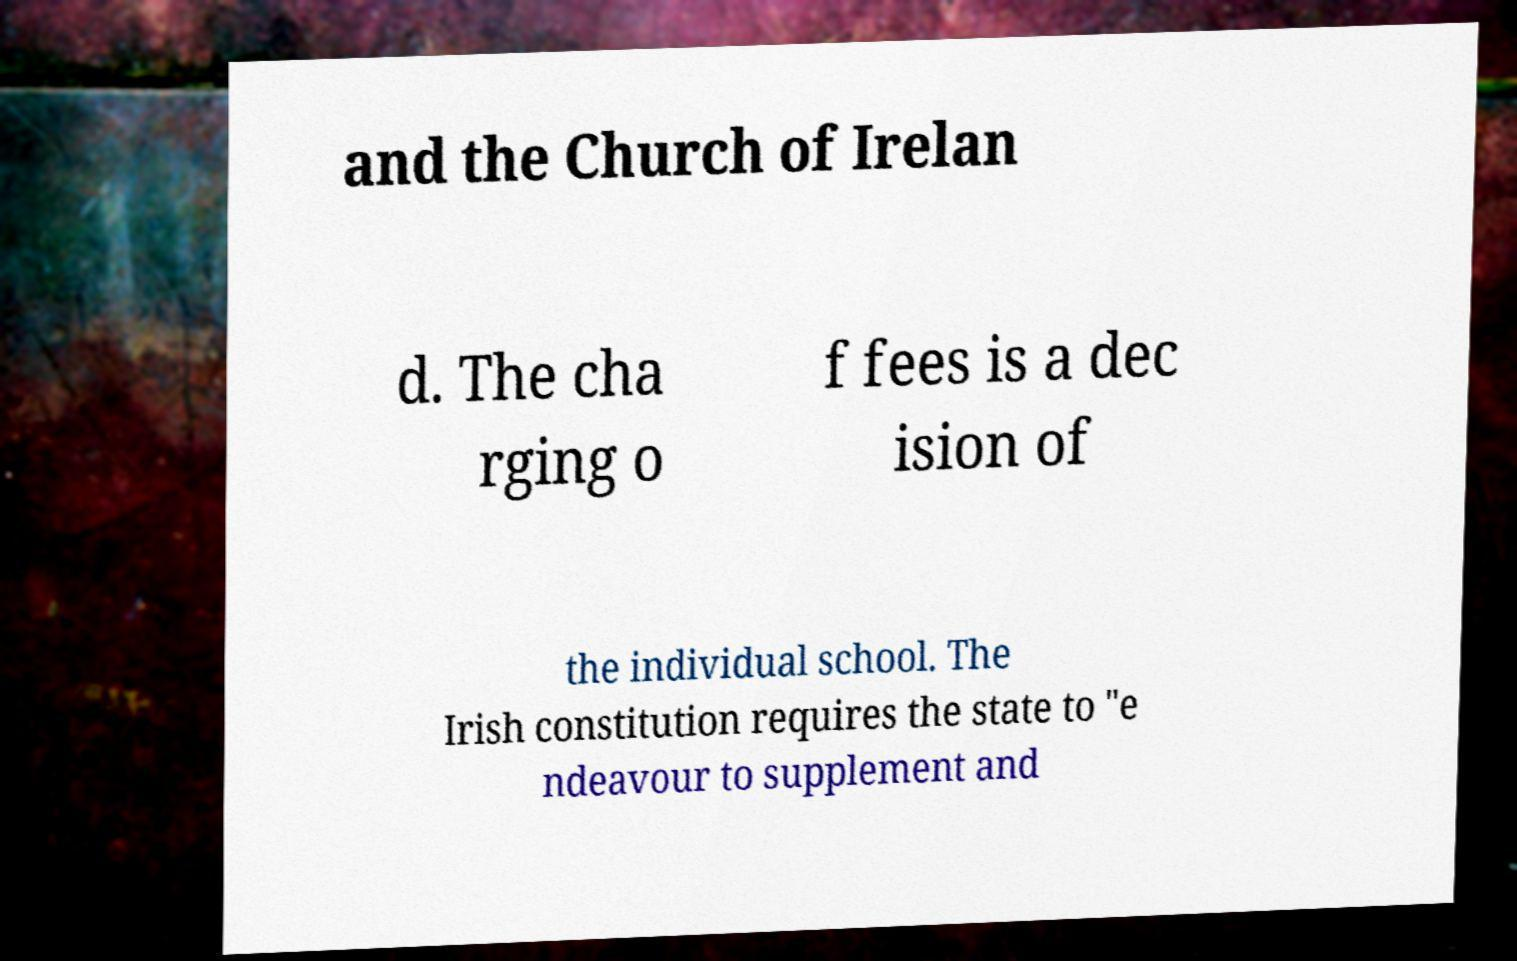Can you accurately transcribe the text from the provided image for me? and the Church of Irelan d. The cha rging o f fees is a dec ision of the individual school. The Irish constitution requires the state to "e ndeavour to supplement and 